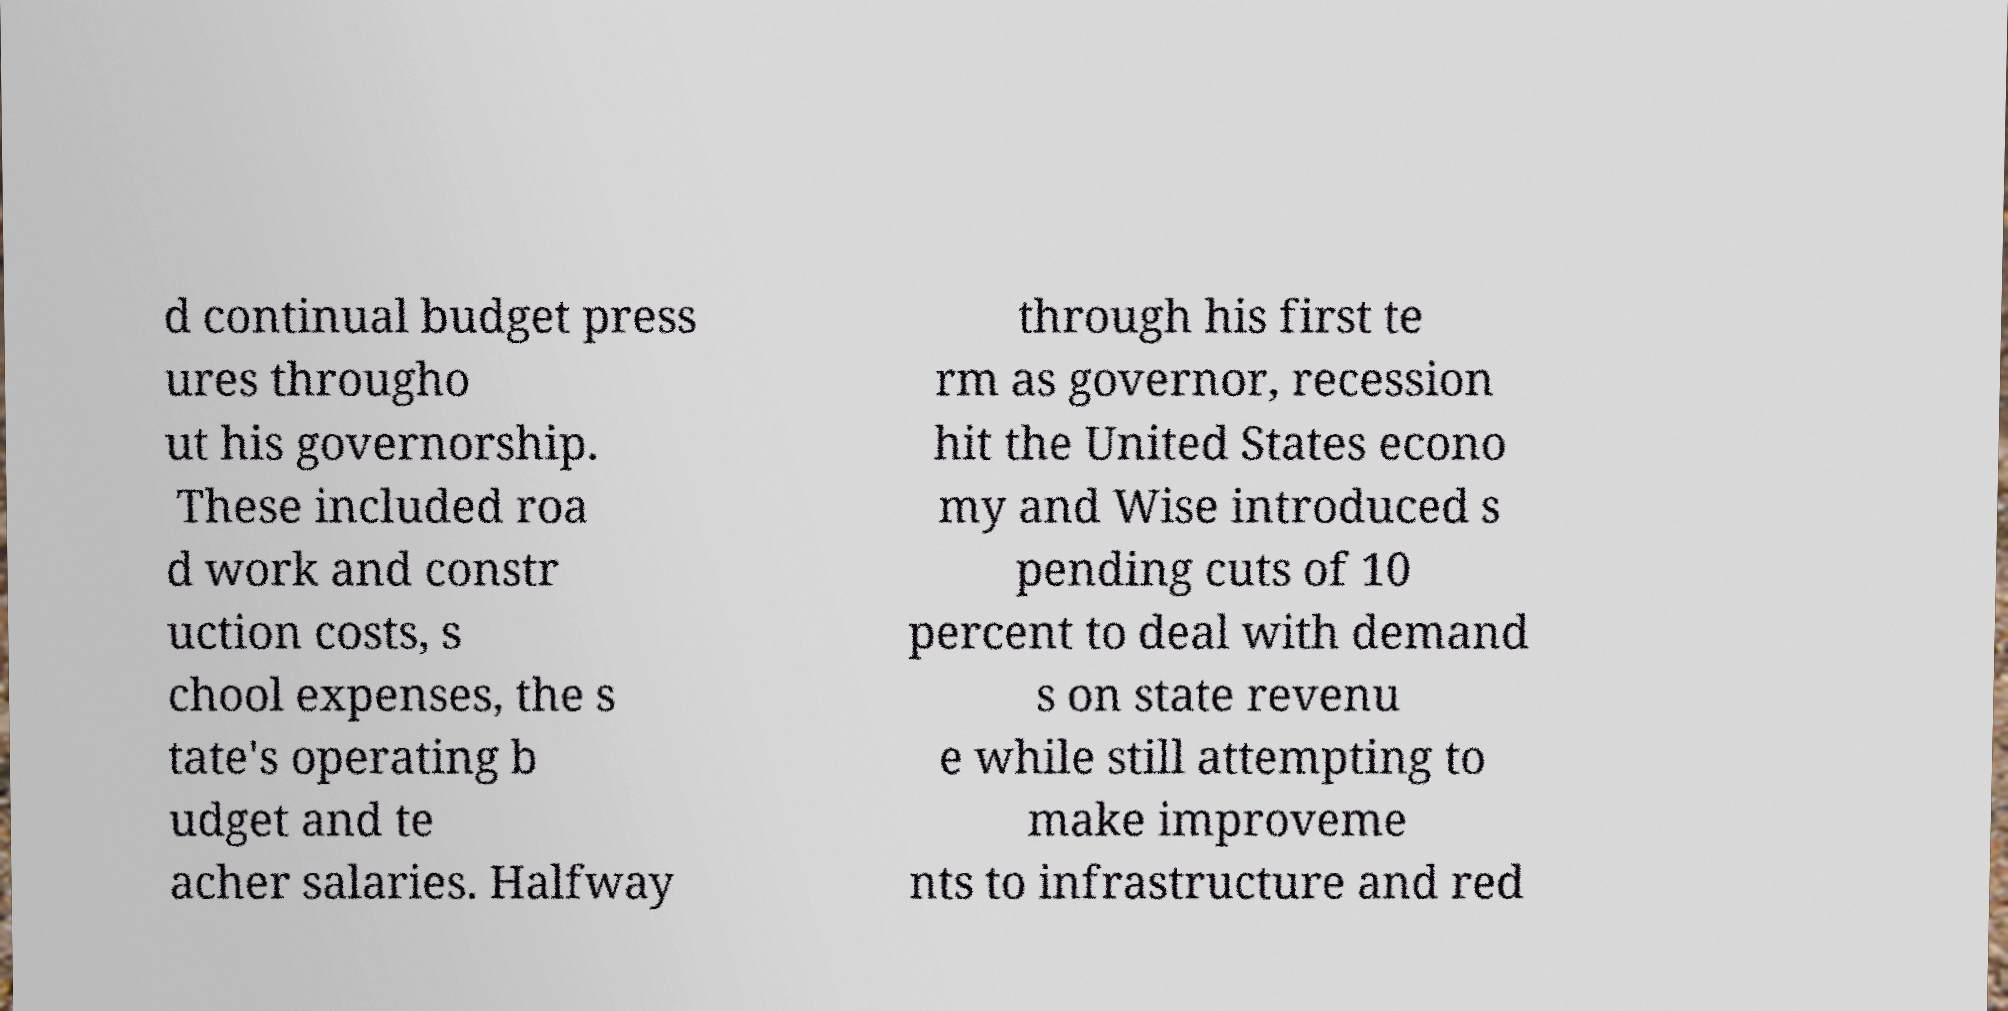Please identify and transcribe the text found in this image. d continual budget press ures througho ut his governorship. These included roa d work and constr uction costs, s chool expenses, the s tate's operating b udget and te acher salaries. Halfway through his first te rm as governor, recession hit the United States econo my and Wise introduced s pending cuts of 10 percent to deal with demand s on state revenu e while still attempting to make improveme nts to infrastructure and red 